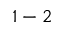<formula> <loc_0><loc_0><loc_500><loc_500>1 - 2</formula> 